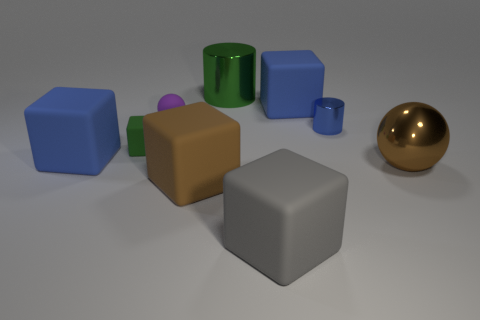The large metallic thing that is on the right side of the green metallic cylinder has what shape?
Your answer should be very brief. Sphere. There is a sphere that is right of the large cylinder; is its color the same as the small matte thing that is on the left side of the small purple sphere?
Your response must be concise. No. What size is the block that is the same color as the metallic ball?
Give a very brief answer. Large. Are any tiny purple metal spheres visible?
Provide a succinct answer. No. What shape is the blue rubber thing behind the blue rubber cube that is in front of the large blue object right of the large green shiny thing?
Offer a terse response. Cube. What number of metallic spheres are left of the big brown shiny thing?
Give a very brief answer. 0. Is the blue block that is on the right side of the big gray thing made of the same material as the brown block?
Provide a short and direct response. Yes. What number of other things are there of the same shape as the gray matte object?
Offer a terse response. 4. How many blue rubber objects are behind the green object to the left of the cylinder behind the tiny ball?
Your answer should be compact. 1. What is the color of the sphere to the left of the small blue metallic object?
Give a very brief answer. Purple. 